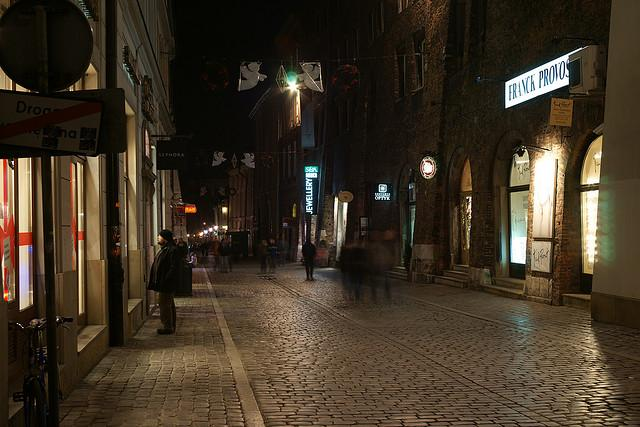What zone is depicted in the photo? Please explain your reasoning. shopping. There are many shops. 